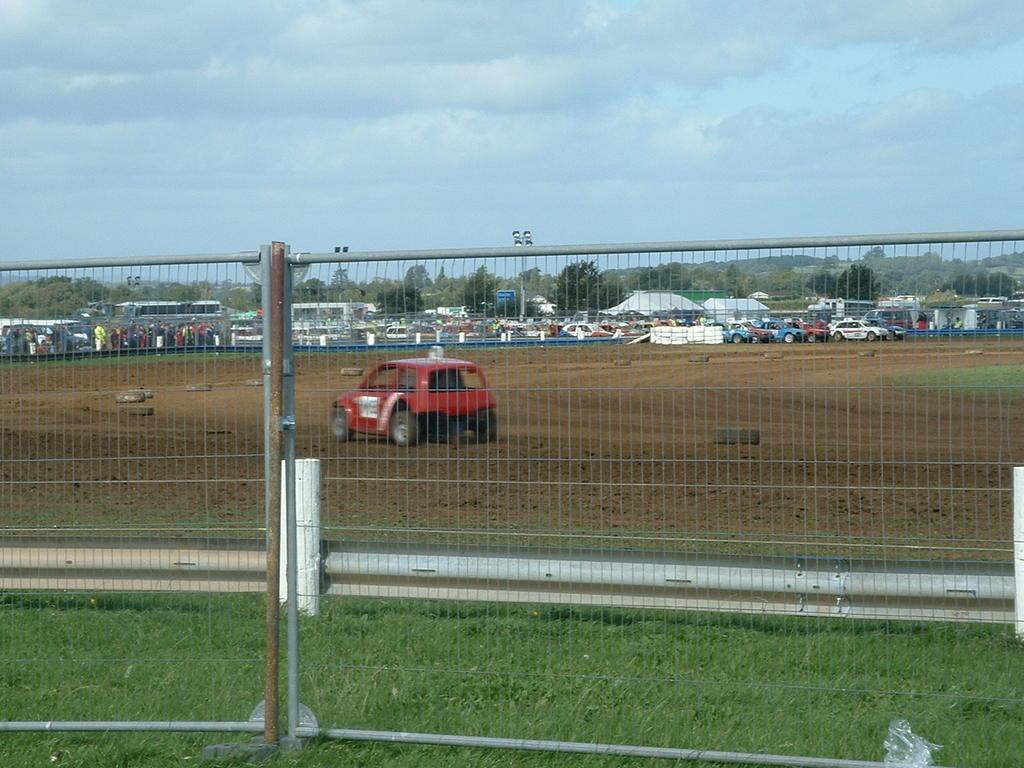Could you give a brief overview of what you see in this image? In this picture I can see there is a car and there are many other cars in the backdrop and I can see there are few other people and in the backdrop there are trees and the sky is clear. 